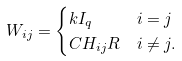<formula> <loc_0><loc_0><loc_500><loc_500>W _ { i j } & = \begin{cases} k I _ { q } & i = j \\ C H _ { i j } R & i \ne j . \end{cases}</formula> 